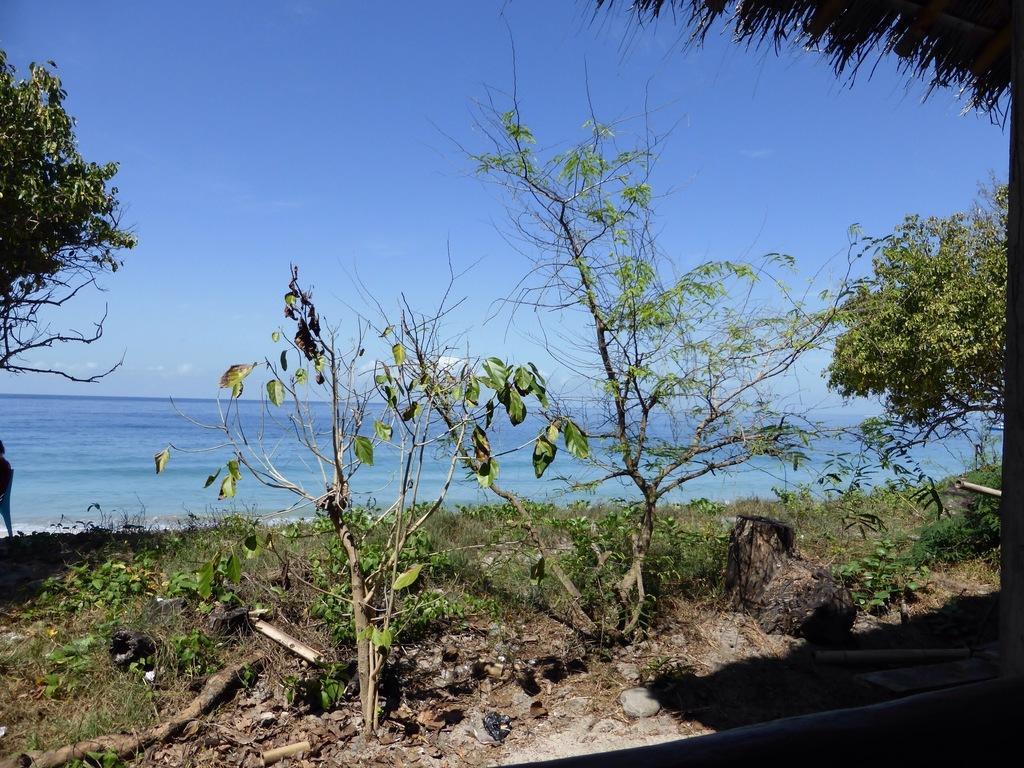In one or two sentences, can you explain what this image depicts? In the image there is are few plants and trees on the grassland and in the front its a beach and above its sky. 